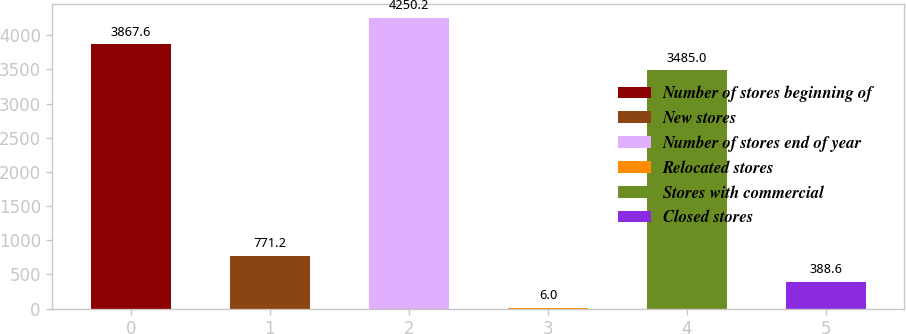<chart> <loc_0><loc_0><loc_500><loc_500><bar_chart><fcel>Number of stores beginning of<fcel>New stores<fcel>Number of stores end of year<fcel>Relocated stores<fcel>Stores with commercial<fcel>Closed stores<nl><fcel>3867.6<fcel>771.2<fcel>4250.2<fcel>6<fcel>3485<fcel>388.6<nl></chart> 